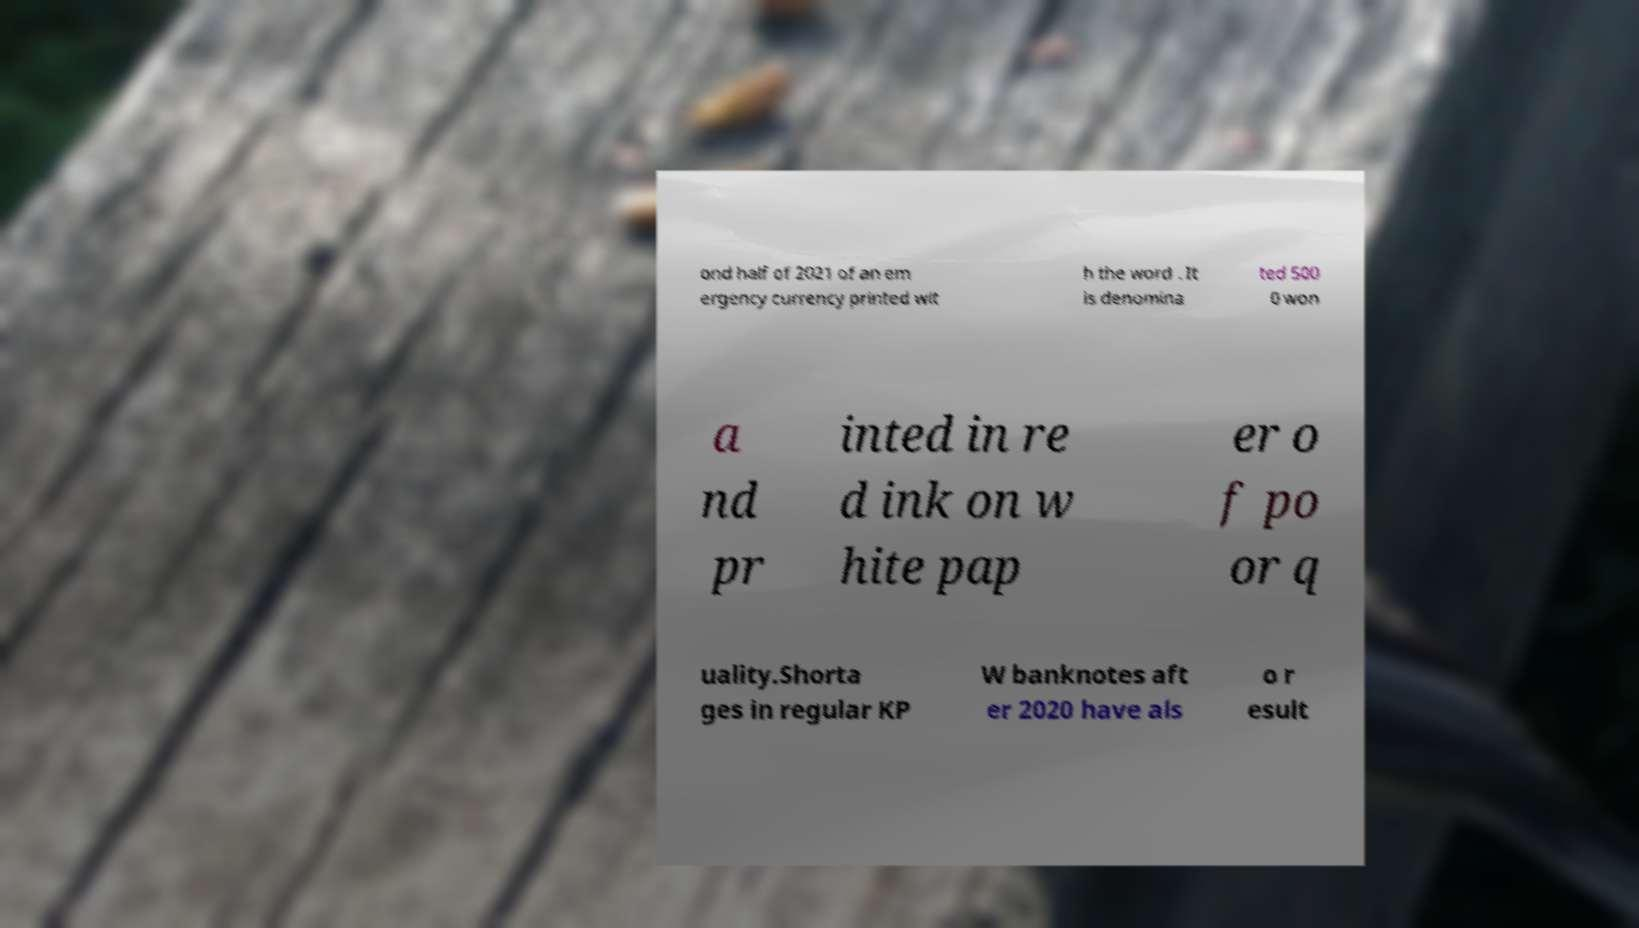I need the written content from this picture converted into text. Can you do that? ond half of 2021 of an em ergency currency printed wit h the word . It is denomina ted 500 0 won a nd pr inted in re d ink on w hite pap er o f po or q uality.Shorta ges in regular KP W banknotes aft er 2020 have als o r esult 